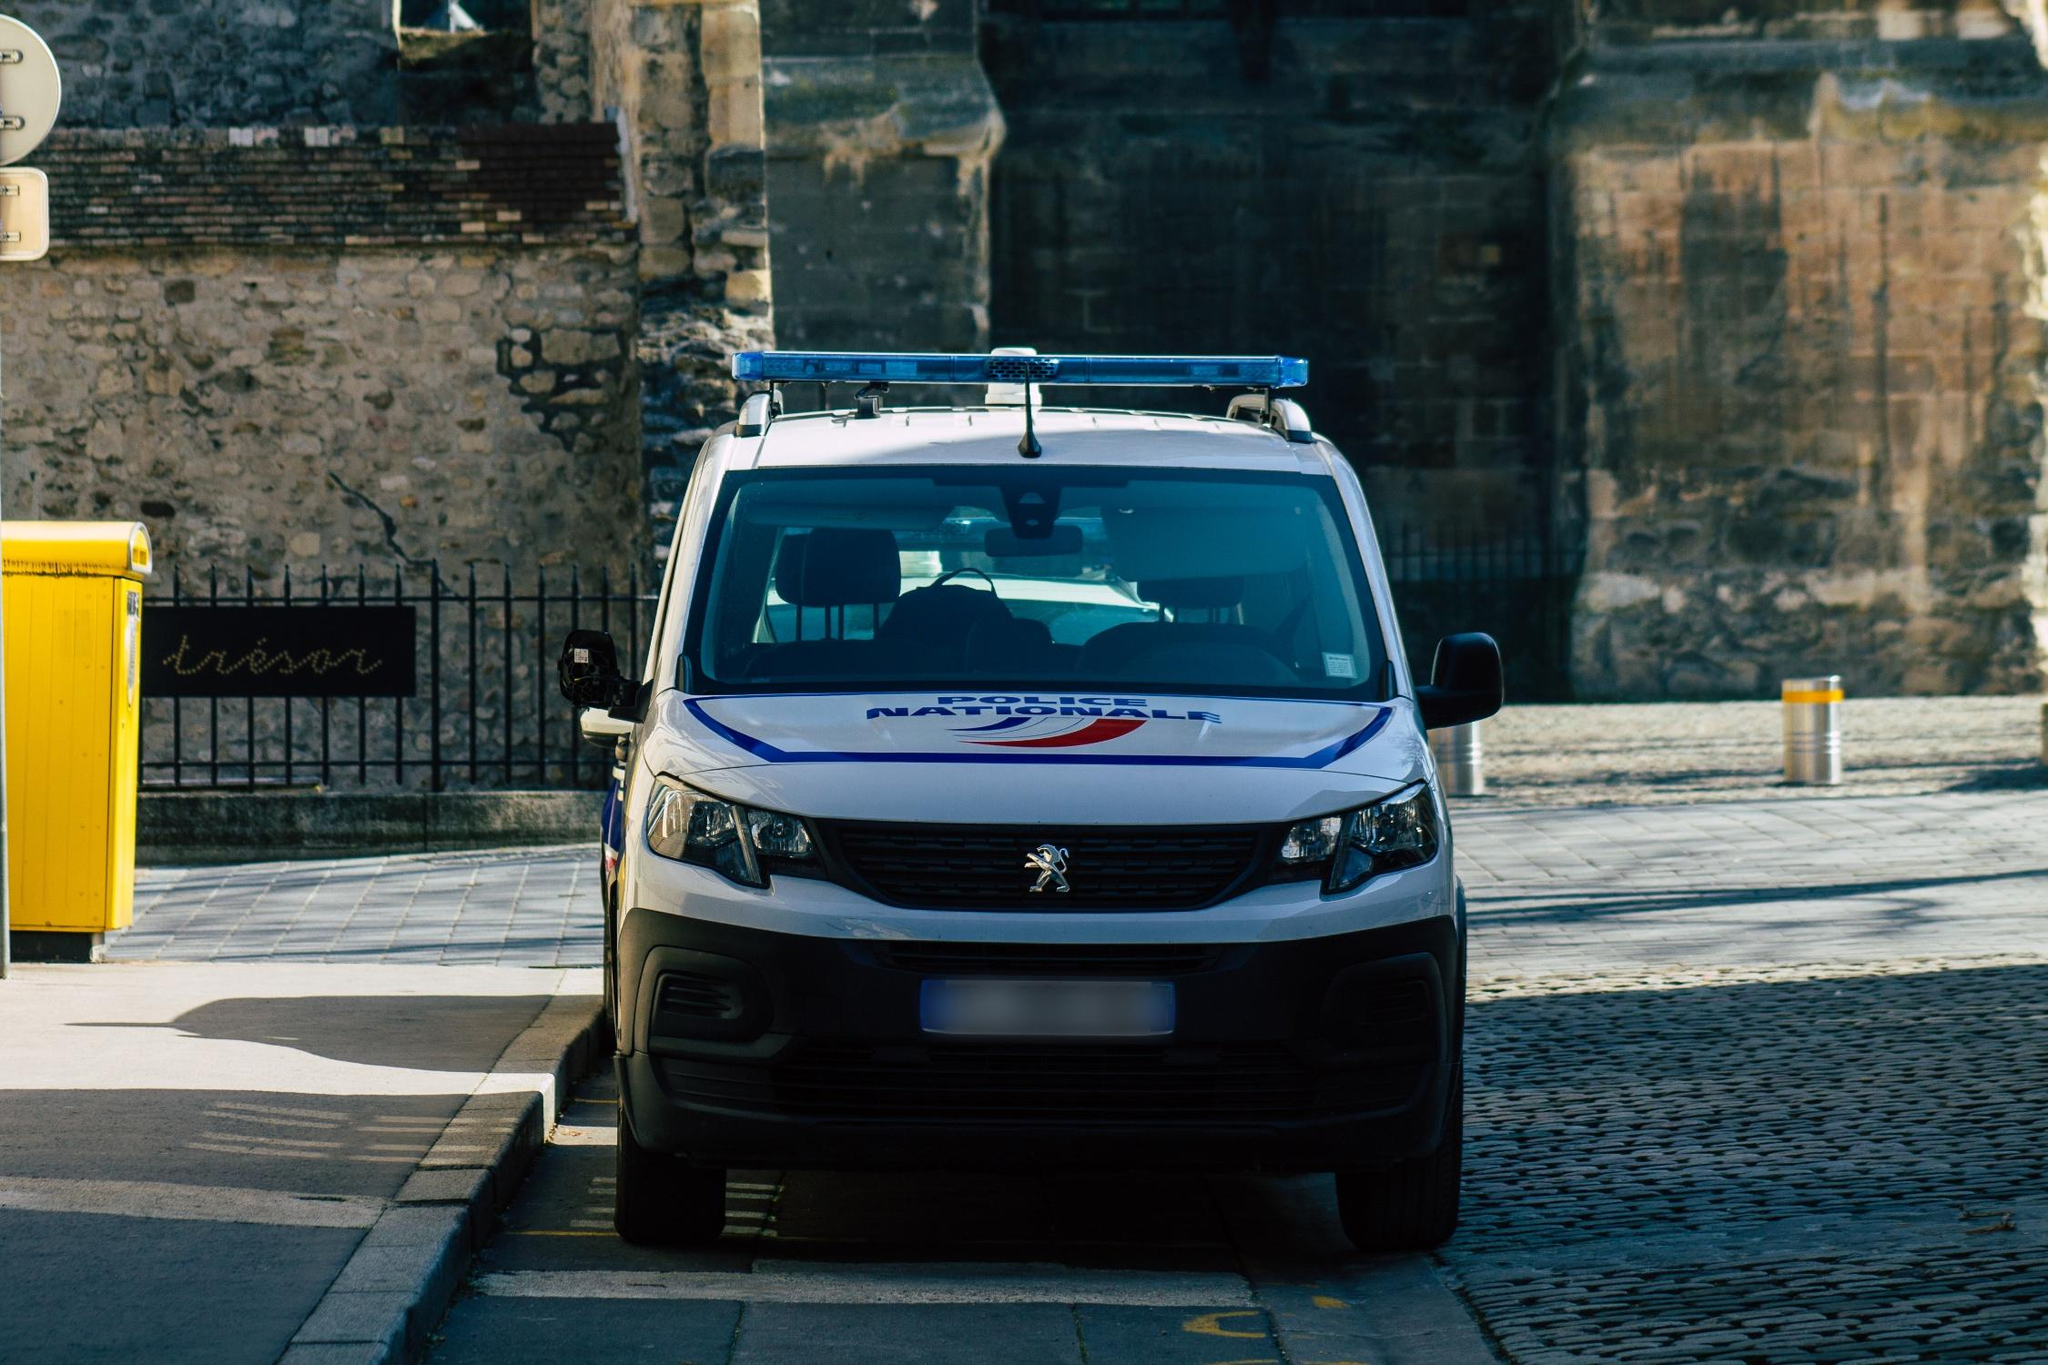Can you elaborate on the elements of the picture provided?
 The image captures a scene on a cobblestone street, where a white Peugeot van is parked. The van is adorned with a blue and red logo on its hood, and a roof rack carrying a ladder, suggesting it might be used for commercial purposes or maintenance work. The street is lined with yellow bollards, adding a pop of color to the scene, and a yellow trash can stands nearby.

In the background, a stone wall provides a rustic backdrop to the urban setting. A window and a door punctuate the wall, hinting at the presence of a building or residence behind it. The cobblestone street, the stone wall, and the old-style window and door suggest that this might be a historic or older part of town.

As for the landmark, the code 'sa_11461' suggests that this location could be in Riyadh, Saudi Arabia[^1^][^3^]. However, without more specific details or distinctive features in the image, it's challenging to identify the exact landmark. The van and the surroundings do not provide clear clues about a specific worldwide landmark. The image seems to depict a rather ordinary, everyday scene in a city, rather than a famous landmark or tourist attraction. 